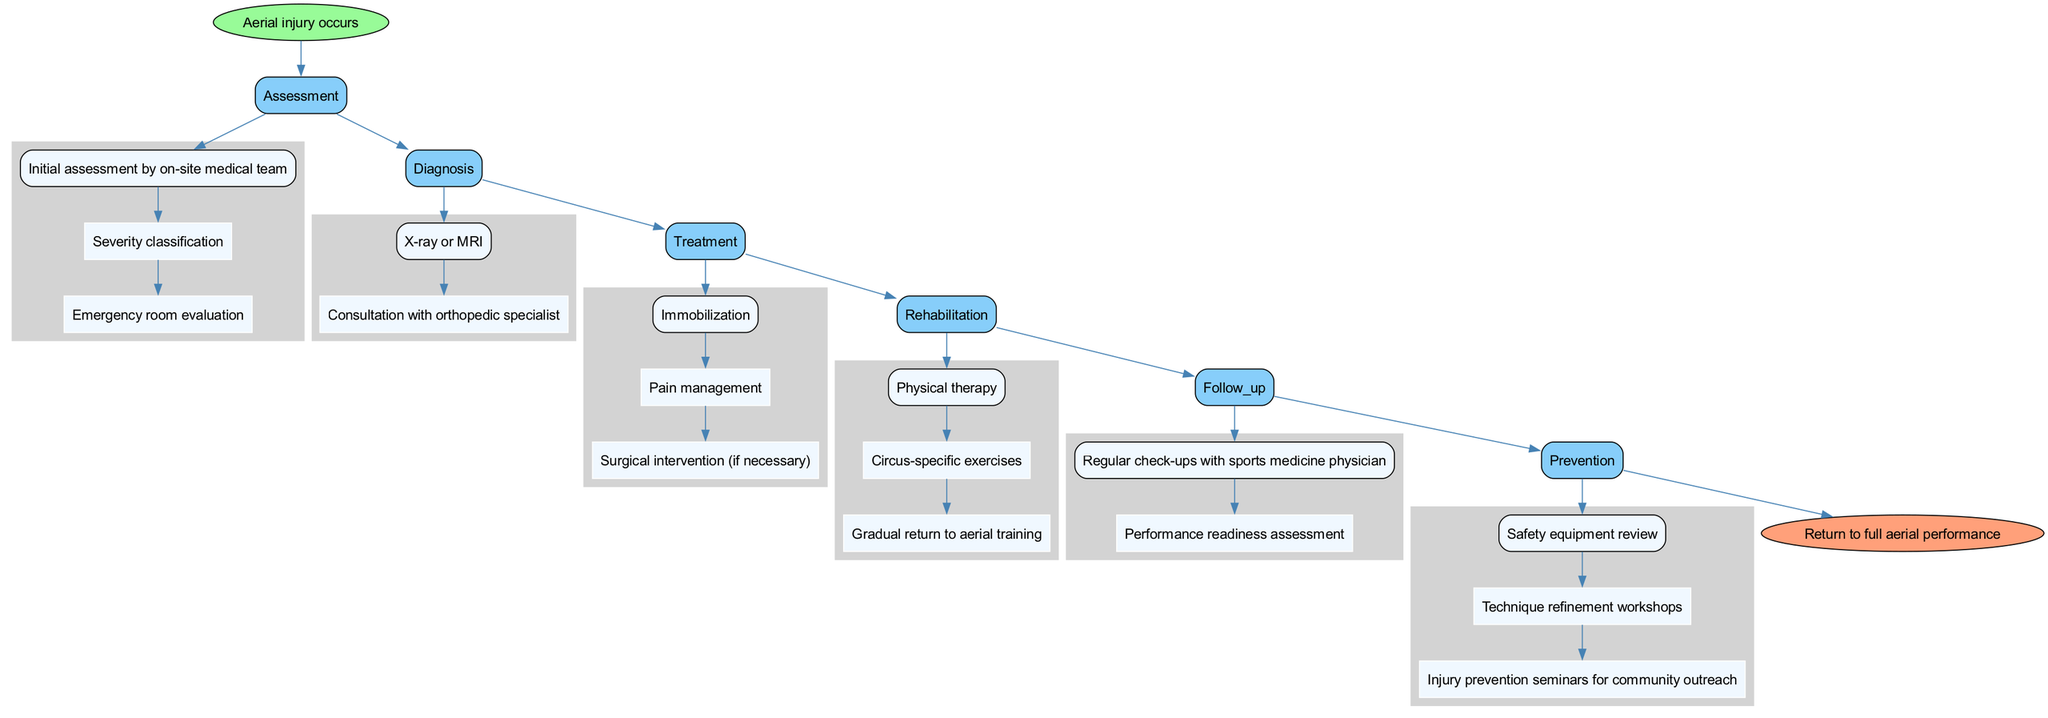What is the first step after an aerial injury? The diagram shows that the first step after an aerial injury is the "Initial assessment by on-site medical team" under the assessment category, which connects directly to the start of the pathway.
Answer: Initial assessment by on-site medical team How many main steps are there in the clinical pathway? By examining the diagram, we can count the main steps listed: assessment, diagnosis, treatment, rehabilitation, follow-up, and prevention, totaling six steps.
Answer: 6 What type of professionals are consulted during the diagnosis phase? The diagnosis phase includes a "Consultation with orthopedic specialist" as indicated in the diagnosis sub-steps, showing the type of professional involved.
Answer: Orthopedic specialist Which treatment is required if necessary? Referring to the treatment section, it specifically mentions "Surgical intervention (if necessary)" as a part of the pathway, indicating it is conditional based on the situation.
Answer: Surgical intervention What is the last step of the pathway? The final node in the diagram connects from prevention to the end, which states "Return to full aerial performance," indicating it is the last step in this clinical pathway.
Answer: Return to full aerial performance Which step precedes rehabilitation in the pathway? The diagram portrays that "treatment" directly leads into "rehabilitation," showing the sequential relationship between these two main categories.
Answer: Treatment What is included in the prevention phase? Under the prevention category, there are sub-steps such as "Safety equipment review," "Technique refinement workshops," and "Injury prevention seminars for community outreach," all defining the content of this phase.
Answer: Safety equipment review, Technique refinement workshops, Injury prevention seminars for community outreach What assessment is performed after the initial evaluation? Following the initial assessment by the on-site medical team, the next step is "Severity classification" as shown in the assessment flow, indicating a sequential evaluation process.
Answer: Severity classification How does the follow-up phase relate to rehabilitation? The follow-up phase occurs after rehabilitation in the diagram and is indicated to involve "Regular check-ups with sports medicine physician" and "Performance readiness assessment," which implies that rehabilitation precedes these follow-ups.
Answer: Rehabilitation precedes follow-up 